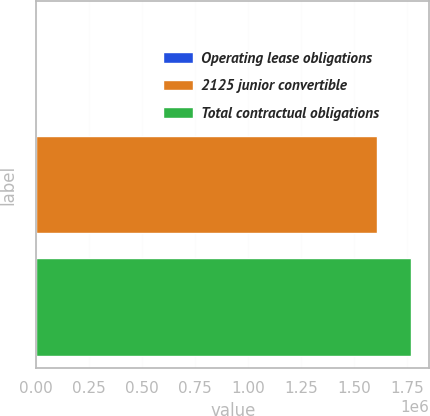<chart> <loc_0><loc_0><loc_500><loc_500><bar_chart><fcel>Operating lease obligations<fcel>2125 junior convertible<fcel>Total contractual obligations<nl><fcel>399<fcel>1.60718e+06<fcel>1.7679e+06<nl></chart> 